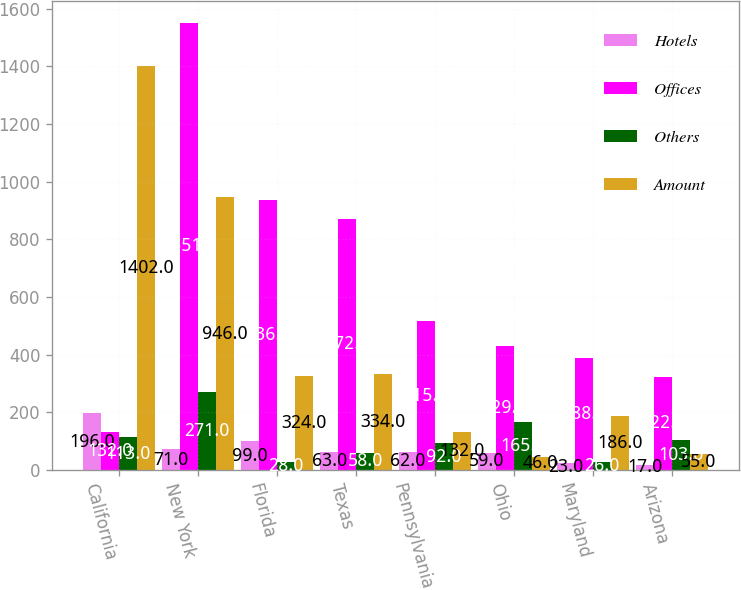Convert chart to OTSL. <chart><loc_0><loc_0><loc_500><loc_500><stacked_bar_chart><ecel><fcel>California<fcel>New York<fcel>Florida<fcel>Texas<fcel>Pennsylvania<fcel>Ohio<fcel>Maryland<fcel>Arizona<nl><fcel>Hotels<fcel>196<fcel>71<fcel>99<fcel>63<fcel>62<fcel>59<fcel>23<fcel>17<nl><fcel>Offices<fcel>132<fcel>1551<fcel>936<fcel>872<fcel>515<fcel>429<fcel>388<fcel>322<nl><fcel>Others<fcel>113<fcel>271<fcel>28<fcel>58<fcel>92<fcel>165<fcel>26<fcel>103<nl><fcel>Amount<fcel>1402<fcel>946<fcel>324<fcel>334<fcel>132<fcel>46<fcel>186<fcel>55<nl></chart> 